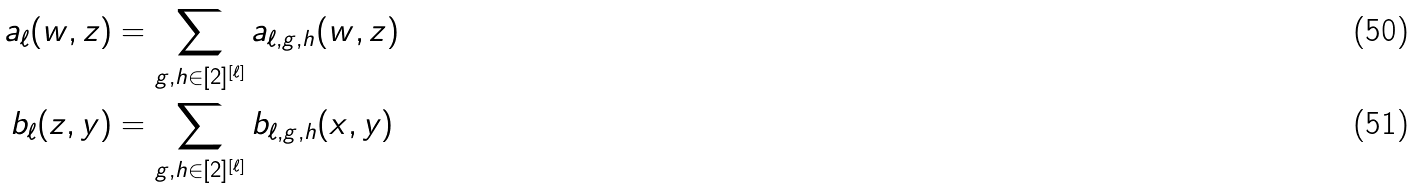Convert formula to latex. <formula><loc_0><loc_0><loc_500><loc_500>a _ { \ell } ( w , z ) & = \sum _ { g , h \in [ 2 ] ^ { [ \ell ] } } a _ { \ell , g , h } ( w , z ) \\ b _ { \ell } ( z , y ) & = \sum _ { g , h \in [ 2 ] ^ { [ \ell ] } } b _ { \ell , g , h } ( x , y )</formula> 